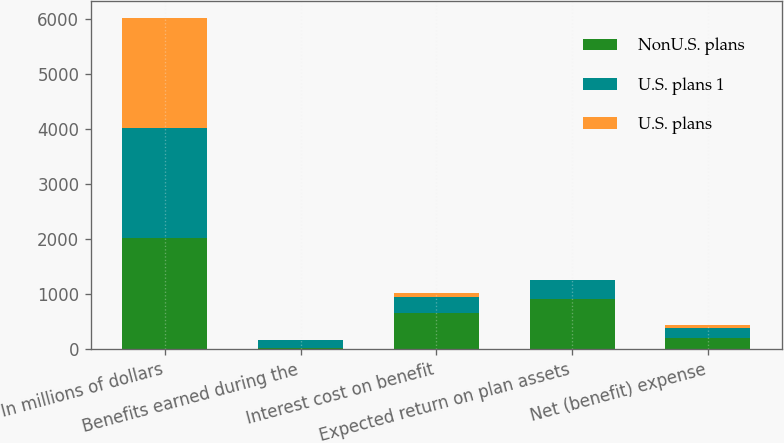<chart> <loc_0><loc_0><loc_500><loc_500><stacked_bar_chart><ecel><fcel>In millions of dollars<fcel>Benefits earned during the<fcel>Interest cost on benefit<fcel>Expected return on plan assets<fcel>Net (benefit) expense<nl><fcel>NonU.S. plans<fcel>2009<fcel>18<fcel>649<fcel>912<fcel>189<nl><fcel>U.S. plans 1<fcel>2009<fcel>148<fcel>301<fcel>336<fcel>198<nl><fcel>U.S. plans<fcel>2009<fcel>1<fcel>61<fcel>10<fcel>53<nl></chart> 